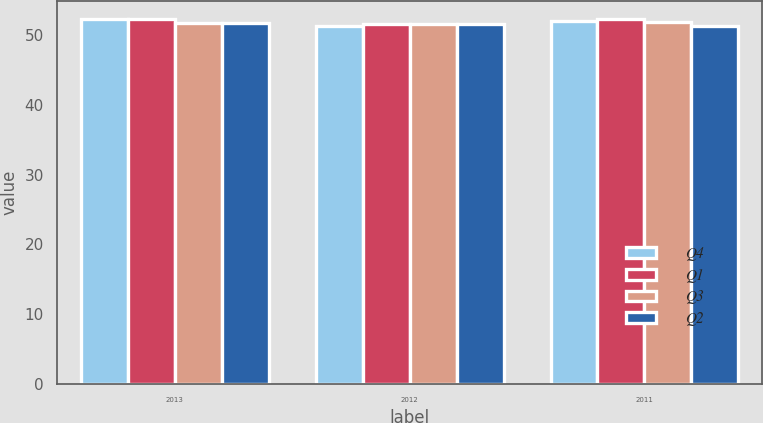<chart> <loc_0><loc_0><loc_500><loc_500><stacked_bar_chart><ecel><fcel>2013<fcel>2012<fcel>2011<nl><fcel>Q4<fcel>52.3<fcel>51.3<fcel>52<nl><fcel>Q1<fcel>52.2<fcel>51.6<fcel>52.2<nl><fcel>Q3<fcel>51.7<fcel>51.6<fcel>51.9<nl><fcel>Q2<fcel>51.7<fcel>51.6<fcel>51.2<nl></chart> 